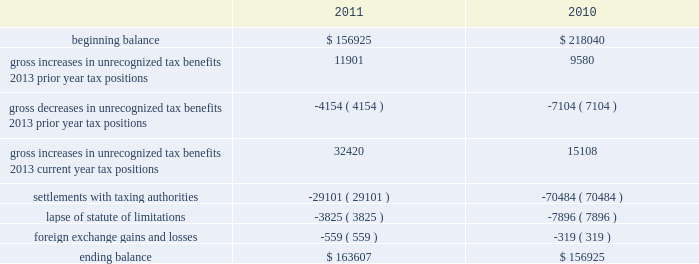A valuation allowance has been established for certain deferred tax assets related to the impairment of investments .
Accounting for uncertainty in income taxes during fiscal 2011 and 2010 , our aggregate changes in our total gross amount of unrecognized tax benefits are summarized as follows ( in thousands ) : beginning balance gross increases in unrecognized tax benefits 2013 prior year tax positions gross decreases in unrecognized tax benefits 2013 prior year tax positions gross increases in unrecognized tax benefits 2013 current year tax positions settlements with taxing authorities lapse of statute of limitations foreign exchange gains and losses ending balance $ 156925 11901 ( 4154 ) 32420 ( 29101 ) ( 3825 ) $ 163607 $ 218040 ( 7104 ) 15108 ( 70484 ) ( 7896 ) $ 156925 as of december 2 , 2011 , the combined amount of accrued interest and penalties related to tax positions taken on our tax returns and included in non-current income taxes payable was approximately $ 12.3 million .
We file income tax returns in the u.s .
On a federal basis and in many u.s .
State and foreign jurisdictions .
We are subject to the continual examination of our income tax returns by the irs and other domestic and foreign tax authorities .
Our major tax jurisdictions are the u.s. , ireland and california .
For california , ireland and the u.s. , the earliest fiscal years open for examination are 2005 , 2006 and 2008 , respectively .
We regularly assess the likelihood of outcomes resulting from these examinations to determine the adequacy of our provision for income taxes and have reserved for potential adjustments that may result from the current examination .
We believe such estimates to be reasonable ; however , there can be no assurance that the final determination of any of these examinations will not have an adverse effect on our operating results and financial position .
In august 2011 , a canadian income tax examination covering our fiscal years 2005 through 2008 was completed .
Our accrued tax and interest related to these years was approximately $ 35 million and was previously reported in long-term income taxes payable .
We reclassified approximately $ 17 million to short-term income taxes payable and decreased deferred tax assets by approximately $ 18 million in conjunction with the aforementioned resolution .
The $ 17 million balance in short-term income taxes payable is partially secured by a letter of credit and is expected to be paid by the first quarter of fiscal 2012 .
In october 2010 , a u.s .
Income tax examination covering our fiscal years 2005 through 2007 was completed .
Our accrued tax and interest related to these years was $ 59 million and was previously reported in long-term income taxes payable .
We paid $ 20 million in conjunction with the aforementioned resolution .
A net income statement tax benefit in the fourth quarter of fiscal 2010 of $ 39 million resulted .
The timing of the resolution of income tax examinations is highly uncertain as are the amounts and timing of tax payments that are part of any audit settlement process .
These events could cause large fluctuations in the balance sheet classification of current and non-current assets and liabilities .
The company believes that before the end of fiscal 2012 , it is reasonably possible that either certain audits will conclude or statutes of limitations on certain income tax examination periods will expire , or both .
Given the uncertainties described above , we can only determine a range of estimated potential decreases in underlying unrecognized tax benefits ranging from $ 0 to approximately $ 40 million .
These amounts would decrease income tax expense under current gaap related to income taxes .
Note 11 .
Restructuring fiscal 2011 restructuring plan in the fourth quarter of fiscal 2011 , in order to better align our resources around our digital media and digital marketing strategies , we initiated a restructuring plan consisting of reductions of approximately 700 full-time positions worldwide and we recorded restructuring charges of approximately $ 78.6 million related to ongoing termination benefits for the position eliminated .
Table of contents adobe systems incorporated notes to consolidated financial statements ( continued ) .
A valuation allowance has been established for certain deferred tax assets related to the impairment of investments .
Accounting for uncertainty in income taxes during fiscal 2011 and 2010 , our aggregate changes in our total gross amount of unrecognized tax benefits are summarized as follows ( in thousands ) : beginning balance gross increases in unrecognized tax benefits 2013 prior year tax positions gross decreases in unrecognized tax benefits 2013 prior year tax positions gross increases in unrecognized tax benefits 2013 current year tax positions settlements with taxing authorities lapse of statute of limitations foreign exchange gains and losses ending balance $ 156925 11901 ( 4154 ) 32420 ( 29101 ) ( 3825 ) $ 163607 $ 218040 ( 7104 ) 15108 ( 70484 ) ( 7896 ) $ 156925 as of december 2 , 2011 , the combined amount of accrued interest and penalties related to tax positions taken on our tax returns and included in non-current income taxes payable was approximately $ 12.3 million .
We file income tax returns in the u.s .
On a federal basis and in many u.s .
State and foreign jurisdictions .
We are subject to the continual examination of our income tax returns by the irs and other domestic and foreign tax authorities .
Our major tax jurisdictions are the u.s. , ireland and california .
For california , ireland and the u.s. , the earliest fiscal years open for examination are 2005 , 2006 and 2008 , respectively .
We regularly assess the likelihood of outcomes resulting from these examinations to determine the adequacy of our provision for income taxes and have reserved for potential adjustments that may result from the current examination .
We believe such estimates to be reasonable ; however , there can be no assurance that the final determination of any of these examinations will not have an adverse effect on our operating results and financial position .
In august 2011 , a canadian income tax examination covering our fiscal years 2005 through 2008 was completed .
Our accrued tax and interest related to these years was approximately $ 35 million and was previously reported in long-term income taxes payable .
We reclassified approximately $ 17 million to short-term income taxes payable and decreased deferred tax assets by approximately $ 18 million in conjunction with the aforementioned resolution .
The $ 17 million balance in short-term income taxes payable is partially secured by a letter of credit and is expected to be paid by the first quarter of fiscal 2012 .
In october 2010 , a u.s .
Income tax examination covering our fiscal years 2005 through 2007 was completed .
Our accrued tax and interest related to these years was $ 59 million and was previously reported in long-term income taxes payable .
We paid $ 20 million in conjunction with the aforementioned resolution .
A net income statement tax benefit in the fourth quarter of fiscal 2010 of $ 39 million resulted .
The timing of the resolution of income tax examinations is highly uncertain as are the amounts and timing of tax payments that are part of any audit settlement process .
These events could cause large fluctuations in the balance sheet classification of current and non-current assets and liabilities .
The company believes that before the end of fiscal 2012 , it is reasonably possible that either certain audits will conclude or statutes of limitations on certain income tax examination periods will expire , or both .
Given the uncertainties described above , we can only determine a range of estimated potential decreases in underlying unrecognized tax benefits ranging from $ 0 to approximately $ 40 million .
These amounts would decrease income tax expense under current gaap related to income taxes .
Note 11 .
Restructuring fiscal 2011 restructuring plan in the fourth quarter of fiscal 2011 , in order to better align our resources around our digital media and digital marketing strategies , we initiated a restructuring plan consisting of reductions of approximately 700 full-time positions worldwide and we recorded restructuring charges of approximately $ 78.6 million related to ongoing termination benefits for the position eliminated .
Table of contents adobe systems incorporated notes to consolidated financial statements ( continued ) .
What is the growth rate in the balance of unrecognized tax benefits during 2010? 
Computations: ((156925 - 218040) / 218040)
Answer: -0.28029. 